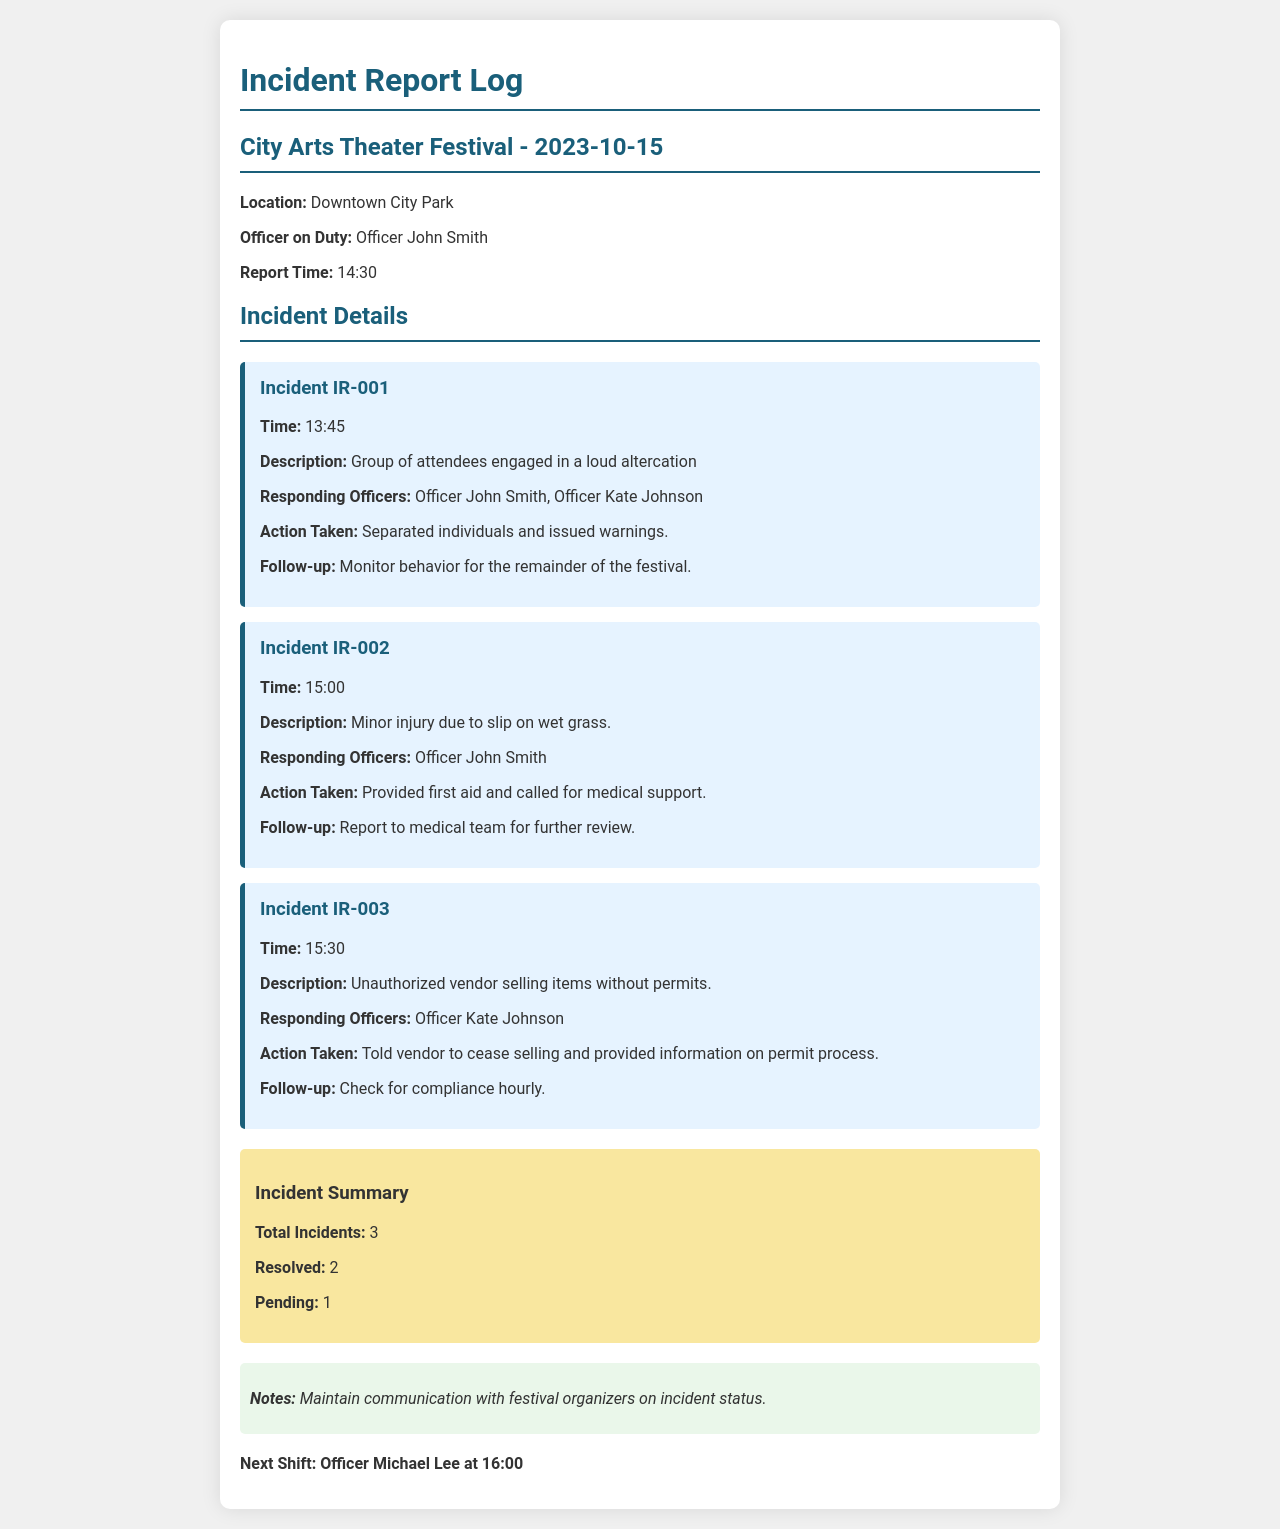What is the date of the festival? The date of the festival is listed in the title of the incident report log.
Answer: 2023-10-15 Who is the officer on duty? The officer on duty is mentioned directly after the date and location.
Answer: Officer John Smith How many total incidents were reported? The total number of incidents is specified in the incident summary section.
Answer: 3 What time did the first incident occur? The time of the first incident is provided in the details of Incident IR-001.
Answer: 13:45 What action was taken for the second incident? The action taken for the second incident is noted in Incident IR-002.
Answer: Provided first aid and called for medical support Which officer responded to the unauthorized vendor incident? The responding officer for Incident IR-003 is detailed in the incident report.
Answer: Officer Kate Johnson What is the pending status of the incidents? The pending status of the incidents is provided in the incident summary.
Answer: 1 What is noted in the document as important for communication? The notes section emphasizes the necessity of communication.
Answer: Maintain communication with festival organizers on incident status What time is the next shift scheduled? The next shift details are provided at the end of the document.
Answer: 16:00 